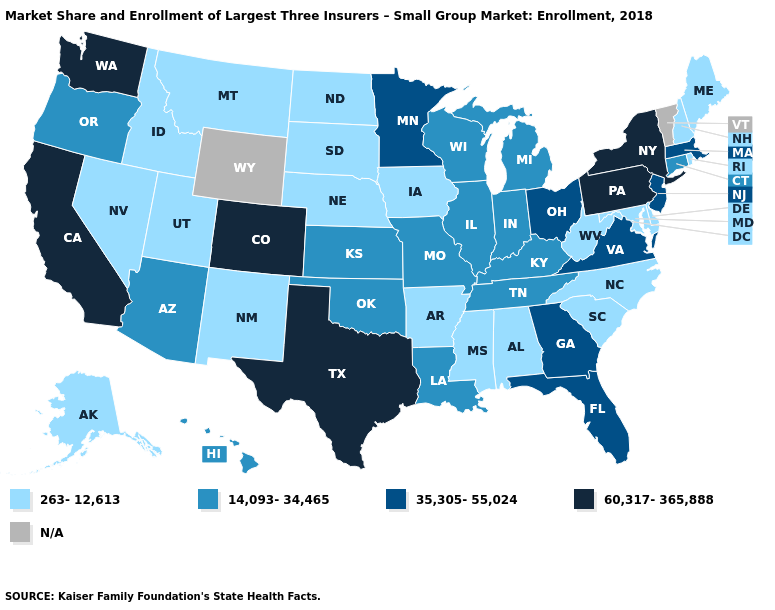What is the lowest value in the Northeast?
Give a very brief answer. 263-12,613. Name the states that have a value in the range N/A?
Concise answer only. Vermont, Wyoming. What is the value of Mississippi?
Be succinct. 263-12,613. Among the states that border New Jersey , does Delaware have the lowest value?
Answer briefly. Yes. Which states hav the highest value in the MidWest?
Keep it brief. Minnesota, Ohio. Among the states that border Minnesota , which have the highest value?
Be succinct. Wisconsin. Name the states that have a value in the range 60,317-365,888?
Answer briefly. California, Colorado, New York, Pennsylvania, Texas, Washington. Among the states that border Rhode Island , which have the lowest value?
Concise answer only. Connecticut. Which states have the highest value in the USA?
Short answer required. California, Colorado, New York, Pennsylvania, Texas, Washington. Is the legend a continuous bar?
Give a very brief answer. No. What is the value of New York?
Concise answer only. 60,317-365,888. Among the states that border Kentucky , does Illinois have the highest value?
Concise answer only. No. Does the map have missing data?
Give a very brief answer. Yes. 